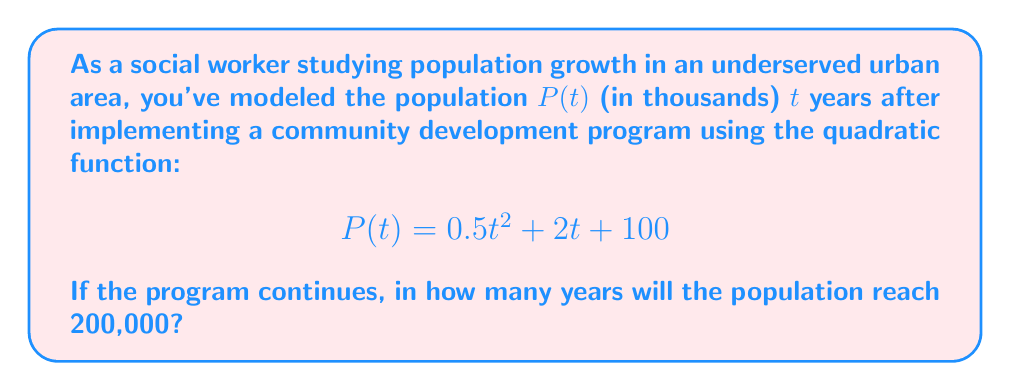Provide a solution to this math problem. To solve this problem, we need to follow these steps:

1) The population will reach 200,000 when P(t) = 200. Since P(t) is given in thousands, we need to solve:

   $$0.5t^2 + 2t + 100 = 200$$

2) Subtract 200 from both sides:

   $$0.5t^2 + 2t - 100 = 0$$

3) Multiply all terms by 2 to eliminate fractions:

   $$t^2 + 4t - 200 = 0$$

4) This is a quadratic equation in the form $at^2 + bt + c = 0$, where $a=1$, $b=4$, and $c=-200$.

5) We can solve this using the quadratic formula: $t = \frac{-b \pm \sqrt{b^2 - 4ac}}{2a}$

6) Substituting our values:

   $$t = \frac{-4 \pm \sqrt{4^2 - 4(1)(-200)}}{2(1)} = \frac{-4 \pm \sqrt{16 + 800}}{2} = \frac{-4 \pm \sqrt{816}}{2}$$

7) Simplify:

   $$t = \frac{-4 \pm 28.57}{2}$$

8) This gives us two solutions:

   $$t = \frac{-4 + 28.57}{2} = 12.285$$ or $$t = \frac{-4 - 28.57}{2} = -16.285$$

9) Since time cannot be negative in this context, we discard the negative solution.

Therefore, the population will reach 200,000 after approximately 12.285 years.
Answer: 12.285 years 